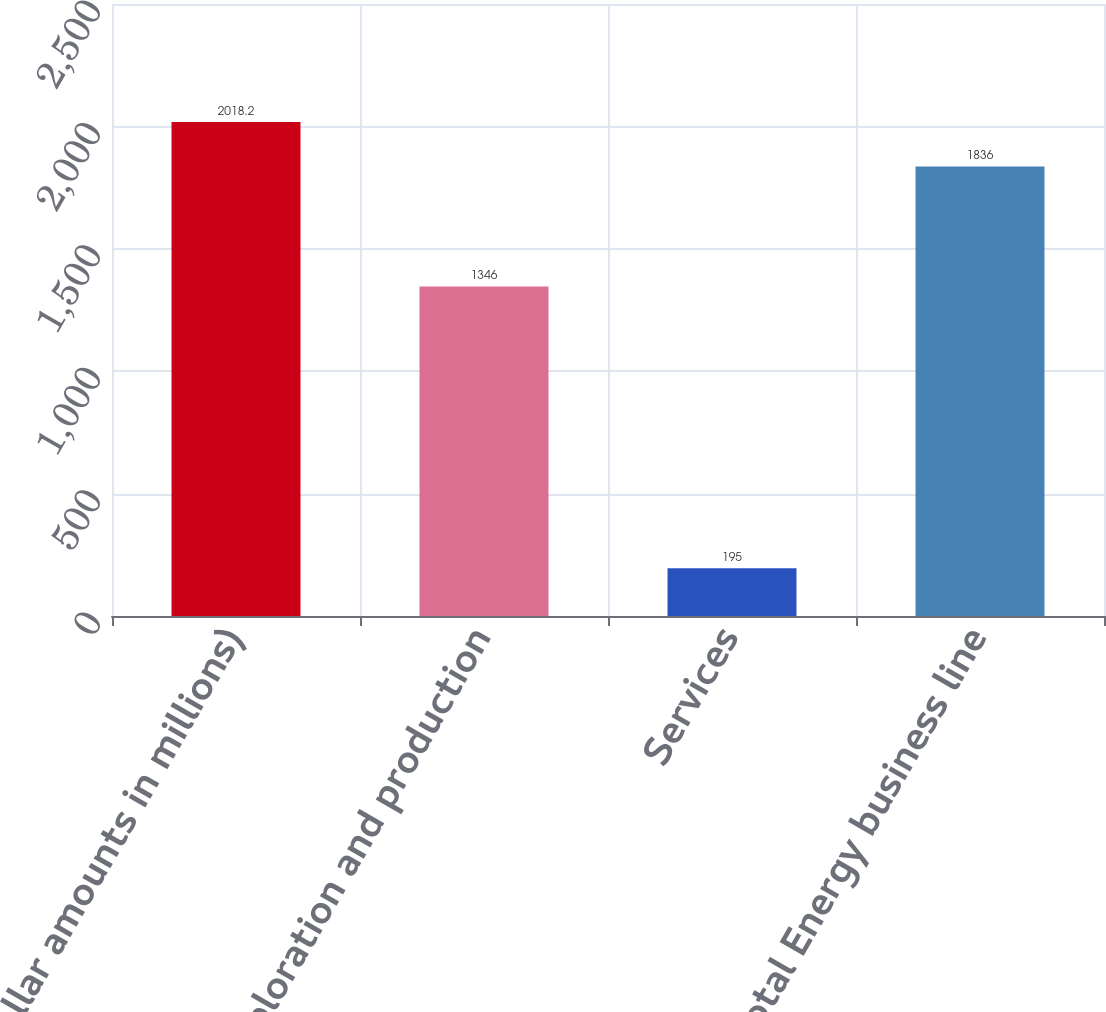Convert chart to OTSL. <chart><loc_0><loc_0><loc_500><loc_500><bar_chart><fcel>(dollar amounts in millions)<fcel>Exploration and production<fcel>Services<fcel>Total Energy business line<nl><fcel>2018.2<fcel>1346<fcel>195<fcel>1836<nl></chart> 